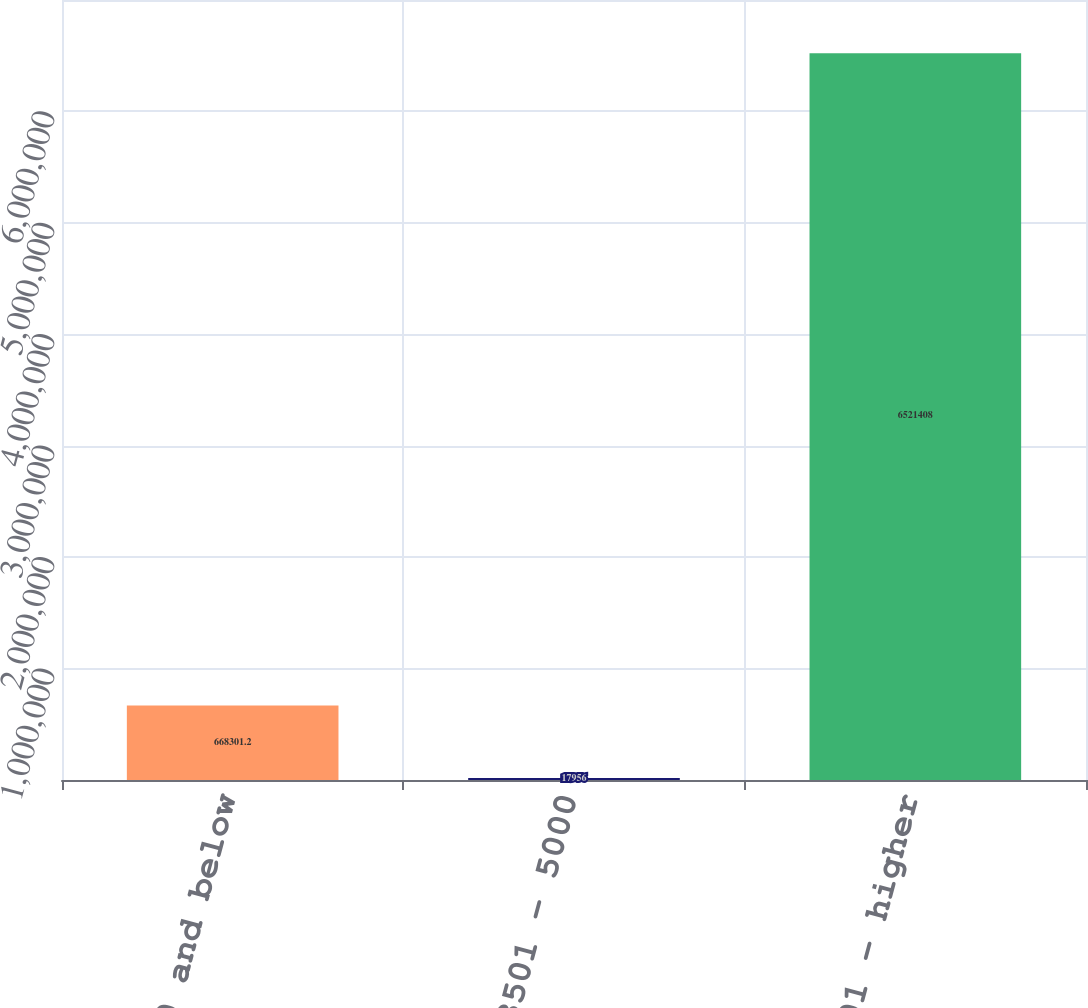Convert chart. <chart><loc_0><loc_0><loc_500><loc_500><bar_chart><fcel>3500 and below<fcel>3501 - 5000<fcel>5001 - higher<nl><fcel>668301<fcel>17956<fcel>6.52141e+06<nl></chart> 